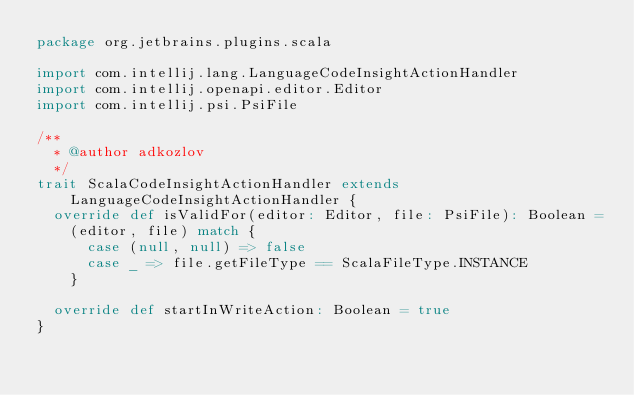<code> <loc_0><loc_0><loc_500><loc_500><_Scala_>package org.jetbrains.plugins.scala

import com.intellij.lang.LanguageCodeInsightActionHandler
import com.intellij.openapi.editor.Editor
import com.intellij.psi.PsiFile

/**
  * @author adkozlov
  */
trait ScalaCodeInsightActionHandler extends LanguageCodeInsightActionHandler {
  override def isValidFor(editor: Editor, file: PsiFile): Boolean =
    (editor, file) match {
      case (null, null) => false
      case _ => file.getFileType == ScalaFileType.INSTANCE
    }

  override def startInWriteAction: Boolean = true
}
</code> 